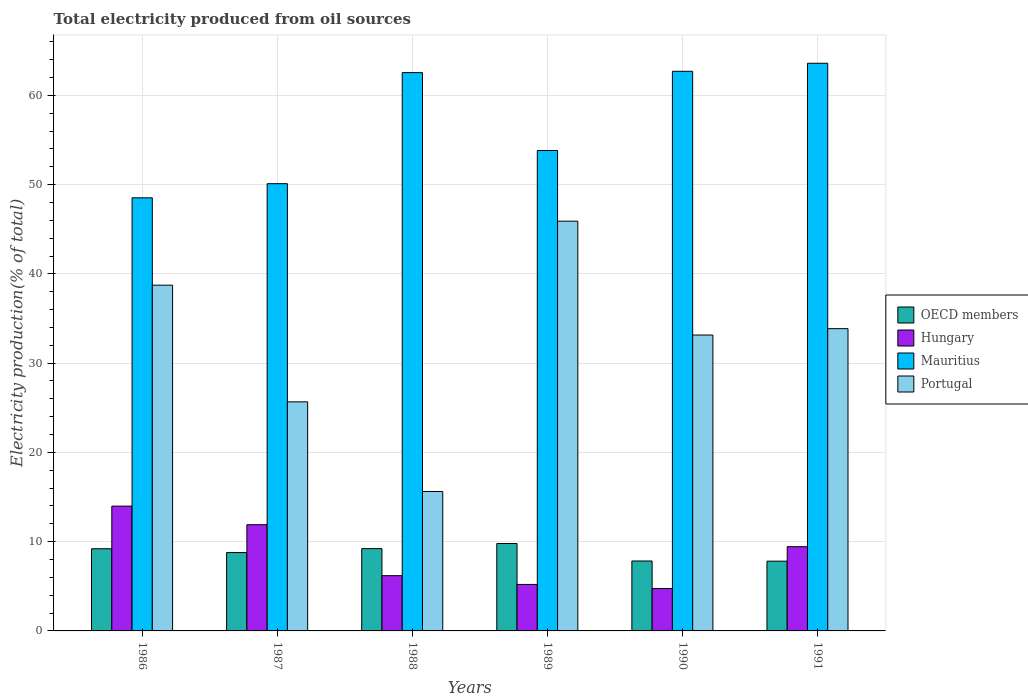How many different coloured bars are there?
Your answer should be very brief. 4. How many bars are there on the 1st tick from the left?
Your response must be concise. 4. What is the total electricity produced in Hungary in 1991?
Give a very brief answer. 9.43. Across all years, what is the maximum total electricity produced in Hungary?
Your answer should be very brief. 13.98. Across all years, what is the minimum total electricity produced in Hungary?
Provide a succinct answer. 4.75. In which year was the total electricity produced in Hungary maximum?
Offer a terse response. 1986. In which year was the total electricity produced in OECD members minimum?
Provide a succinct answer. 1991. What is the total total electricity produced in OECD members in the graph?
Keep it short and to the point. 52.65. What is the difference between the total electricity produced in Hungary in 1987 and that in 1988?
Your answer should be very brief. 5.71. What is the difference between the total electricity produced in OECD members in 1989 and the total electricity produced in Hungary in 1990?
Offer a very short reply. 5.04. What is the average total electricity produced in Portugal per year?
Your response must be concise. 32.15. In the year 1987, what is the difference between the total electricity produced in Portugal and total electricity produced in Hungary?
Ensure brevity in your answer.  13.76. What is the ratio of the total electricity produced in Mauritius in 1986 to that in 1988?
Provide a short and direct response. 0.78. Is the total electricity produced in Portugal in 1987 less than that in 1989?
Your answer should be compact. Yes. What is the difference between the highest and the second highest total electricity produced in Portugal?
Offer a very short reply. 7.17. What is the difference between the highest and the lowest total electricity produced in OECD members?
Provide a short and direct response. 1.98. In how many years, is the total electricity produced in Portugal greater than the average total electricity produced in Portugal taken over all years?
Keep it short and to the point. 4. What does the 1st bar from the left in 1991 represents?
Make the answer very short. OECD members. What does the 4th bar from the right in 1991 represents?
Your response must be concise. OECD members. Is it the case that in every year, the sum of the total electricity produced in Mauritius and total electricity produced in Portugal is greater than the total electricity produced in Hungary?
Ensure brevity in your answer.  Yes. Are the values on the major ticks of Y-axis written in scientific E-notation?
Give a very brief answer. No. Does the graph contain grids?
Your answer should be very brief. Yes. Where does the legend appear in the graph?
Make the answer very short. Center right. How are the legend labels stacked?
Give a very brief answer. Vertical. What is the title of the graph?
Provide a succinct answer. Total electricity produced from oil sources. What is the label or title of the Y-axis?
Offer a very short reply. Electricity production(% of total). What is the Electricity production(% of total) in OECD members in 1986?
Your answer should be compact. 9.21. What is the Electricity production(% of total) of Hungary in 1986?
Your answer should be very brief. 13.98. What is the Electricity production(% of total) in Mauritius in 1986?
Provide a short and direct response. 48.52. What is the Electricity production(% of total) of Portugal in 1986?
Keep it short and to the point. 38.73. What is the Electricity production(% of total) in OECD members in 1987?
Provide a short and direct response. 8.78. What is the Electricity production(% of total) in Hungary in 1987?
Your answer should be very brief. 11.9. What is the Electricity production(% of total) of Mauritius in 1987?
Offer a very short reply. 50.1. What is the Electricity production(% of total) in Portugal in 1987?
Give a very brief answer. 25.66. What is the Electricity production(% of total) of OECD members in 1988?
Your response must be concise. 9.22. What is the Electricity production(% of total) of Hungary in 1988?
Give a very brief answer. 6.19. What is the Electricity production(% of total) in Mauritius in 1988?
Keep it short and to the point. 62.55. What is the Electricity production(% of total) in Portugal in 1988?
Provide a succinct answer. 15.62. What is the Electricity production(% of total) of OECD members in 1989?
Your answer should be very brief. 9.79. What is the Electricity production(% of total) in Hungary in 1989?
Offer a very short reply. 5.21. What is the Electricity production(% of total) of Mauritius in 1989?
Your answer should be compact. 53.82. What is the Electricity production(% of total) in Portugal in 1989?
Keep it short and to the point. 45.9. What is the Electricity production(% of total) in OECD members in 1990?
Ensure brevity in your answer.  7.83. What is the Electricity production(% of total) of Hungary in 1990?
Your answer should be very brief. 4.75. What is the Electricity production(% of total) in Mauritius in 1990?
Your response must be concise. 62.69. What is the Electricity production(% of total) in Portugal in 1990?
Ensure brevity in your answer.  33.15. What is the Electricity production(% of total) in OECD members in 1991?
Provide a succinct answer. 7.82. What is the Electricity production(% of total) in Hungary in 1991?
Provide a succinct answer. 9.43. What is the Electricity production(% of total) in Mauritius in 1991?
Offer a very short reply. 63.59. What is the Electricity production(% of total) in Portugal in 1991?
Your response must be concise. 33.86. Across all years, what is the maximum Electricity production(% of total) in OECD members?
Give a very brief answer. 9.79. Across all years, what is the maximum Electricity production(% of total) in Hungary?
Your answer should be compact. 13.98. Across all years, what is the maximum Electricity production(% of total) in Mauritius?
Give a very brief answer. 63.59. Across all years, what is the maximum Electricity production(% of total) in Portugal?
Ensure brevity in your answer.  45.9. Across all years, what is the minimum Electricity production(% of total) of OECD members?
Keep it short and to the point. 7.82. Across all years, what is the minimum Electricity production(% of total) in Hungary?
Ensure brevity in your answer.  4.75. Across all years, what is the minimum Electricity production(% of total) of Mauritius?
Your answer should be very brief. 48.52. Across all years, what is the minimum Electricity production(% of total) in Portugal?
Offer a very short reply. 15.62. What is the total Electricity production(% of total) in OECD members in the graph?
Offer a very short reply. 52.65. What is the total Electricity production(% of total) in Hungary in the graph?
Your response must be concise. 51.46. What is the total Electricity production(% of total) in Mauritius in the graph?
Give a very brief answer. 341.27. What is the total Electricity production(% of total) of Portugal in the graph?
Offer a very short reply. 192.93. What is the difference between the Electricity production(% of total) of OECD members in 1986 and that in 1987?
Keep it short and to the point. 0.43. What is the difference between the Electricity production(% of total) of Hungary in 1986 and that in 1987?
Make the answer very short. 2.08. What is the difference between the Electricity production(% of total) of Mauritius in 1986 and that in 1987?
Offer a very short reply. -1.58. What is the difference between the Electricity production(% of total) of Portugal in 1986 and that in 1987?
Offer a terse response. 13.07. What is the difference between the Electricity production(% of total) in OECD members in 1986 and that in 1988?
Your answer should be compact. -0.01. What is the difference between the Electricity production(% of total) in Hungary in 1986 and that in 1988?
Give a very brief answer. 7.79. What is the difference between the Electricity production(% of total) in Mauritius in 1986 and that in 1988?
Your response must be concise. -14.03. What is the difference between the Electricity production(% of total) of Portugal in 1986 and that in 1988?
Provide a succinct answer. 23.11. What is the difference between the Electricity production(% of total) in OECD members in 1986 and that in 1989?
Offer a terse response. -0.59. What is the difference between the Electricity production(% of total) of Hungary in 1986 and that in 1989?
Give a very brief answer. 8.78. What is the difference between the Electricity production(% of total) of Mauritius in 1986 and that in 1989?
Offer a very short reply. -5.3. What is the difference between the Electricity production(% of total) in Portugal in 1986 and that in 1989?
Keep it short and to the point. -7.17. What is the difference between the Electricity production(% of total) of OECD members in 1986 and that in 1990?
Offer a very short reply. 1.37. What is the difference between the Electricity production(% of total) in Hungary in 1986 and that in 1990?
Offer a very short reply. 9.23. What is the difference between the Electricity production(% of total) in Mauritius in 1986 and that in 1990?
Your response must be concise. -14.17. What is the difference between the Electricity production(% of total) in Portugal in 1986 and that in 1990?
Your answer should be very brief. 5.58. What is the difference between the Electricity production(% of total) in OECD members in 1986 and that in 1991?
Your answer should be compact. 1.39. What is the difference between the Electricity production(% of total) in Hungary in 1986 and that in 1991?
Keep it short and to the point. 4.55. What is the difference between the Electricity production(% of total) in Mauritius in 1986 and that in 1991?
Keep it short and to the point. -15.07. What is the difference between the Electricity production(% of total) in Portugal in 1986 and that in 1991?
Make the answer very short. 4.87. What is the difference between the Electricity production(% of total) in OECD members in 1987 and that in 1988?
Ensure brevity in your answer.  -0.44. What is the difference between the Electricity production(% of total) in Hungary in 1987 and that in 1988?
Your response must be concise. 5.71. What is the difference between the Electricity production(% of total) of Mauritius in 1987 and that in 1988?
Offer a very short reply. -12.44. What is the difference between the Electricity production(% of total) of Portugal in 1987 and that in 1988?
Ensure brevity in your answer.  10.04. What is the difference between the Electricity production(% of total) in OECD members in 1987 and that in 1989?
Provide a short and direct response. -1.01. What is the difference between the Electricity production(% of total) of Hungary in 1987 and that in 1989?
Provide a short and direct response. 6.69. What is the difference between the Electricity production(% of total) in Mauritius in 1987 and that in 1989?
Keep it short and to the point. -3.72. What is the difference between the Electricity production(% of total) in Portugal in 1987 and that in 1989?
Offer a very short reply. -20.24. What is the difference between the Electricity production(% of total) in OECD members in 1987 and that in 1990?
Provide a succinct answer. 0.95. What is the difference between the Electricity production(% of total) of Hungary in 1987 and that in 1990?
Provide a short and direct response. 7.15. What is the difference between the Electricity production(% of total) in Mauritius in 1987 and that in 1990?
Make the answer very short. -12.59. What is the difference between the Electricity production(% of total) in Portugal in 1987 and that in 1990?
Ensure brevity in your answer.  -7.48. What is the difference between the Electricity production(% of total) in OECD members in 1987 and that in 1991?
Give a very brief answer. 0.96. What is the difference between the Electricity production(% of total) of Hungary in 1987 and that in 1991?
Your answer should be compact. 2.46. What is the difference between the Electricity production(% of total) in Mauritius in 1987 and that in 1991?
Your response must be concise. -13.49. What is the difference between the Electricity production(% of total) in Portugal in 1987 and that in 1991?
Keep it short and to the point. -8.2. What is the difference between the Electricity production(% of total) in OECD members in 1988 and that in 1989?
Offer a terse response. -0.57. What is the difference between the Electricity production(% of total) of Hungary in 1988 and that in 1989?
Keep it short and to the point. 0.98. What is the difference between the Electricity production(% of total) of Mauritius in 1988 and that in 1989?
Your response must be concise. 8.73. What is the difference between the Electricity production(% of total) of Portugal in 1988 and that in 1989?
Offer a very short reply. -30.28. What is the difference between the Electricity production(% of total) in OECD members in 1988 and that in 1990?
Your response must be concise. 1.39. What is the difference between the Electricity production(% of total) in Hungary in 1988 and that in 1990?
Give a very brief answer. 1.44. What is the difference between the Electricity production(% of total) of Mauritius in 1988 and that in 1990?
Offer a terse response. -0.15. What is the difference between the Electricity production(% of total) of Portugal in 1988 and that in 1990?
Provide a short and direct response. -17.53. What is the difference between the Electricity production(% of total) in OECD members in 1988 and that in 1991?
Your response must be concise. 1.4. What is the difference between the Electricity production(% of total) in Hungary in 1988 and that in 1991?
Provide a succinct answer. -3.25. What is the difference between the Electricity production(% of total) in Mauritius in 1988 and that in 1991?
Your answer should be compact. -1.05. What is the difference between the Electricity production(% of total) of Portugal in 1988 and that in 1991?
Keep it short and to the point. -18.24. What is the difference between the Electricity production(% of total) in OECD members in 1989 and that in 1990?
Your answer should be compact. 1.96. What is the difference between the Electricity production(% of total) in Hungary in 1989 and that in 1990?
Your response must be concise. 0.46. What is the difference between the Electricity production(% of total) of Mauritius in 1989 and that in 1990?
Provide a succinct answer. -8.87. What is the difference between the Electricity production(% of total) of Portugal in 1989 and that in 1990?
Provide a short and direct response. 12.76. What is the difference between the Electricity production(% of total) of OECD members in 1989 and that in 1991?
Your response must be concise. 1.98. What is the difference between the Electricity production(% of total) of Hungary in 1989 and that in 1991?
Provide a short and direct response. -4.23. What is the difference between the Electricity production(% of total) of Mauritius in 1989 and that in 1991?
Ensure brevity in your answer.  -9.77. What is the difference between the Electricity production(% of total) in Portugal in 1989 and that in 1991?
Keep it short and to the point. 12.04. What is the difference between the Electricity production(% of total) of OECD members in 1990 and that in 1991?
Your answer should be very brief. 0.02. What is the difference between the Electricity production(% of total) in Hungary in 1990 and that in 1991?
Give a very brief answer. -4.68. What is the difference between the Electricity production(% of total) of Mauritius in 1990 and that in 1991?
Give a very brief answer. -0.9. What is the difference between the Electricity production(% of total) in Portugal in 1990 and that in 1991?
Give a very brief answer. -0.71. What is the difference between the Electricity production(% of total) in OECD members in 1986 and the Electricity production(% of total) in Hungary in 1987?
Offer a terse response. -2.69. What is the difference between the Electricity production(% of total) of OECD members in 1986 and the Electricity production(% of total) of Mauritius in 1987?
Your response must be concise. -40.9. What is the difference between the Electricity production(% of total) in OECD members in 1986 and the Electricity production(% of total) in Portugal in 1987?
Give a very brief answer. -16.46. What is the difference between the Electricity production(% of total) in Hungary in 1986 and the Electricity production(% of total) in Mauritius in 1987?
Make the answer very short. -36.12. What is the difference between the Electricity production(% of total) of Hungary in 1986 and the Electricity production(% of total) of Portugal in 1987?
Keep it short and to the point. -11.68. What is the difference between the Electricity production(% of total) in Mauritius in 1986 and the Electricity production(% of total) in Portugal in 1987?
Your answer should be compact. 22.86. What is the difference between the Electricity production(% of total) of OECD members in 1986 and the Electricity production(% of total) of Hungary in 1988?
Your answer should be very brief. 3.02. What is the difference between the Electricity production(% of total) of OECD members in 1986 and the Electricity production(% of total) of Mauritius in 1988?
Offer a terse response. -53.34. What is the difference between the Electricity production(% of total) of OECD members in 1986 and the Electricity production(% of total) of Portugal in 1988?
Provide a succinct answer. -6.41. What is the difference between the Electricity production(% of total) of Hungary in 1986 and the Electricity production(% of total) of Mauritius in 1988?
Make the answer very short. -48.56. What is the difference between the Electricity production(% of total) of Hungary in 1986 and the Electricity production(% of total) of Portugal in 1988?
Make the answer very short. -1.64. What is the difference between the Electricity production(% of total) of Mauritius in 1986 and the Electricity production(% of total) of Portugal in 1988?
Your response must be concise. 32.9. What is the difference between the Electricity production(% of total) of OECD members in 1986 and the Electricity production(% of total) of Hungary in 1989?
Your answer should be very brief. 4. What is the difference between the Electricity production(% of total) in OECD members in 1986 and the Electricity production(% of total) in Mauritius in 1989?
Keep it short and to the point. -44.61. What is the difference between the Electricity production(% of total) of OECD members in 1986 and the Electricity production(% of total) of Portugal in 1989?
Your answer should be very brief. -36.7. What is the difference between the Electricity production(% of total) in Hungary in 1986 and the Electricity production(% of total) in Mauritius in 1989?
Give a very brief answer. -39.84. What is the difference between the Electricity production(% of total) of Hungary in 1986 and the Electricity production(% of total) of Portugal in 1989?
Ensure brevity in your answer.  -31.92. What is the difference between the Electricity production(% of total) in Mauritius in 1986 and the Electricity production(% of total) in Portugal in 1989?
Provide a succinct answer. 2.62. What is the difference between the Electricity production(% of total) of OECD members in 1986 and the Electricity production(% of total) of Hungary in 1990?
Give a very brief answer. 4.46. What is the difference between the Electricity production(% of total) in OECD members in 1986 and the Electricity production(% of total) in Mauritius in 1990?
Provide a short and direct response. -53.49. What is the difference between the Electricity production(% of total) of OECD members in 1986 and the Electricity production(% of total) of Portugal in 1990?
Your response must be concise. -23.94. What is the difference between the Electricity production(% of total) in Hungary in 1986 and the Electricity production(% of total) in Mauritius in 1990?
Your response must be concise. -48.71. What is the difference between the Electricity production(% of total) of Hungary in 1986 and the Electricity production(% of total) of Portugal in 1990?
Your answer should be compact. -19.17. What is the difference between the Electricity production(% of total) in Mauritius in 1986 and the Electricity production(% of total) in Portugal in 1990?
Your answer should be compact. 15.37. What is the difference between the Electricity production(% of total) in OECD members in 1986 and the Electricity production(% of total) in Hungary in 1991?
Provide a succinct answer. -0.23. What is the difference between the Electricity production(% of total) of OECD members in 1986 and the Electricity production(% of total) of Mauritius in 1991?
Offer a terse response. -54.39. What is the difference between the Electricity production(% of total) in OECD members in 1986 and the Electricity production(% of total) in Portugal in 1991?
Ensure brevity in your answer.  -24.65. What is the difference between the Electricity production(% of total) in Hungary in 1986 and the Electricity production(% of total) in Mauritius in 1991?
Your response must be concise. -49.61. What is the difference between the Electricity production(% of total) in Hungary in 1986 and the Electricity production(% of total) in Portugal in 1991?
Provide a short and direct response. -19.88. What is the difference between the Electricity production(% of total) in Mauritius in 1986 and the Electricity production(% of total) in Portugal in 1991?
Offer a very short reply. 14.66. What is the difference between the Electricity production(% of total) in OECD members in 1987 and the Electricity production(% of total) in Hungary in 1988?
Make the answer very short. 2.59. What is the difference between the Electricity production(% of total) of OECD members in 1987 and the Electricity production(% of total) of Mauritius in 1988?
Your answer should be compact. -53.77. What is the difference between the Electricity production(% of total) in OECD members in 1987 and the Electricity production(% of total) in Portugal in 1988?
Your answer should be very brief. -6.84. What is the difference between the Electricity production(% of total) in Hungary in 1987 and the Electricity production(% of total) in Mauritius in 1988?
Your answer should be compact. -50.65. What is the difference between the Electricity production(% of total) in Hungary in 1987 and the Electricity production(% of total) in Portugal in 1988?
Offer a terse response. -3.72. What is the difference between the Electricity production(% of total) in Mauritius in 1987 and the Electricity production(% of total) in Portugal in 1988?
Keep it short and to the point. 34.48. What is the difference between the Electricity production(% of total) in OECD members in 1987 and the Electricity production(% of total) in Hungary in 1989?
Your answer should be compact. 3.57. What is the difference between the Electricity production(% of total) of OECD members in 1987 and the Electricity production(% of total) of Mauritius in 1989?
Provide a short and direct response. -45.04. What is the difference between the Electricity production(% of total) of OECD members in 1987 and the Electricity production(% of total) of Portugal in 1989?
Keep it short and to the point. -37.13. What is the difference between the Electricity production(% of total) of Hungary in 1987 and the Electricity production(% of total) of Mauritius in 1989?
Make the answer very short. -41.92. What is the difference between the Electricity production(% of total) in Hungary in 1987 and the Electricity production(% of total) in Portugal in 1989?
Keep it short and to the point. -34. What is the difference between the Electricity production(% of total) of Mauritius in 1987 and the Electricity production(% of total) of Portugal in 1989?
Offer a very short reply. 4.2. What is the difference between the Electricity production(% of total) of OECD members in 1987 and the Electricity production(% of total) of Hungary in 1990?
Keep it short and to the point. 4.03. What is the difference between the Electricity production(% of total) of OECD members in 1987 and the Electricity production(% of total) of Mauritius in 1990?
Make the answer very short. -53.91. What is the difference between the Electricity production(% of total) in OECD members in 1987 and the Electricity production(% of total) in Portugal in 1990?
Give a very brief answer. -24.37. What is the difference between the Electricity production(% of total) in Hungary in 1987 and the Electricity production(% of total) in Mauritius in 1990?
Offer a terse response. -50.79. What is the difference between the Electricity production(% of total) of Hungary in 1987 and the Electricity production(% of total) of Portugal in 1990?
Offer a terse response. -21.25. What is the difference between the Electricity production(% of total) in Mauritius in 1987 and the Electricity production(% of total) in Portugal in 1990?
Offer a very short reply. 16.96. What is the difference between the Electricity production(% of total) in OECD members in 1987 and the Electricity production(% of total) in Hungary in 1991?
Give a very brief answer. -0.66. What is the difference between the Electricity production(% of total) of OECD members in 1987 and the Electricity production(% of total) of Mauritius in 1991?
Offer a very short reply. -54.82. What is the difference between the Electricity production(% of total) of OECD members in 1987 and the Electricity production(% of total) of Portugal in 1991?
Your answer should be very brief. -25.08. What is the difference between the Electricity production(% of total) in Hungary in 1987 and the Electricity production(% of total) in Mauritius in 1991?
Give a very brief answer. -51.69. What is the difference between the Electricity production(% of total) of Hungary in 1987 and the Electricity production(% of total) of Portugal in 1991?
Offer a terse response. -21.96. What is the difference between the Electricity production(% of total) of Mauritius in 1987 and the Electricity production(% of total) of Portugal in 1991?
Your answer should be very brief. 16.24. What is the difference between the Electricity production(% of total) of OECD members in 1988 and the Electricity production(% of total) of Hungary in 1989?
Provide a short and direct response. 4.01. What is the difference between the Electricity production(% of total) of OECD members in 1988 and the Electricity production(% of total) of Mauritius in 1989?
Offer a very short reply. -44.6. What is the difference between the Electricity production(% of total) in OECD members in 1988 and the Electricity production(% of total) in Portugal in 1989?
Your answer should be compact. -36.68. What is the difference between the Electricity production(% of total) of Hungary in 1988 and the Electricity production(% of total) of Mauritius in 1989?
Offer a terse response. -47.63. What is the difference between the Electricity production(% of total) of Hungary in 1988 and the Electricity production(% of total) of Portugal in 1989?
Your answer should be very brief. -39.72. What is the difference between the Electricity production(% of total) of Mauritius in 1988 and the Electricity production(% of total) of Portugal in 1989?
Offer a very short reply. 16.64. What is the difference between the Electricity production(% of total) of OECD members in 1988 and the Electricity production(% of total) of Hungary in 1990?
Provide a succinct answer. 4.47. What is the difference between the Electricity production(% of total) in OECD members in 1988 and the Electricity production(% of total) in Mauritius in 1990?
Keep it short and to the point. -53.47. What is the difference between the Electricity production(% of total) of OECD members in 1988 and the Electricity production(% of total) of Portugal in 1990?
Keep it short and to the point. -23.93. What is the difference between the Electricity production(% of total) of Hungary in 1988 and the Electricity production(% of total) of Mauritius in 1990?
Your response must be concise. -56.5. What is the difference between the Electricity production(% of total) in Hungary in 1988 and the Electricity production(% of total) in Portugal in 1990?
Keep it short and to the point. -26.96. What is the difference between the Electricity production(% of total) in Mauritius in 1988 and the Electricity production(% of total) in Portugal in 1990?
Offer a very short reply. 29.4. What is the difference between the Electricity production(% of total) of OECD members in 1988 and the Electricity production(% of total) of Hungary in 1991?
Your answer should be compact. -0.22. What is the difference between the Electricity production(% of total) of OECD members in 1988 and the Electricity production(% of total) of Mauritius in 1991?
Your answer should be very brief. -54.37. What is the difference between the Electricity production(% of total) in OECD members in 1988 and the Electricity production(% of total) in Portugal in 1991?
Give a very brief answer. -24.64. What is the difference between the Electricity production(% of total) in Hungary in 1988 and the Electricity production(% of total) in Mauritius in 1991?
Give a very brief answer. -57.41. What is the difference between the Electricity production(% of total) of Hungary in 1988 and the Electricity production(% of total) of Portugal in 1991?
Offer a terse response. -27.67. What is the difference between the Electricity production(% of total) in Mauritius in 1988 and the Electricity production(% of total) in Portugal in 1991?
Your answer should be very brief. 28.68. What is the difference between the Electricity production(% of total) in OECD members in 1989 and the Electricity production(% of total) in Hungary in 1990?
Offer a very short reply. 5.04. What is the difference between the Electricity production(% of total) of OECD members in 1989 and the Electricity production(% of total) of Mauritius in 1990?
Offer a very short reply. -52.9. What is the difference between the Electricity production(% of total) in OECD members in 1989 and the Electricity production(% of total) in Portugal in 1990?
Your answer should be compact. -23.36. What is the difference between the Electricity production(% of total) of Hungary in 1989 and the Electricity production(% of total) of Mauritius in 1990?
Offer a very short reply. -57.49. What is the difference between the Electricity production(% of total) in Hungary in 1989 and the Electricity production(% of total) in Portugal in 1990?
Your response must be concise. -27.94. What is the difference between the Electricity production(% of total) of Mauritius in 1989 and the Electricity production(% of total) of Portugal in 1990?
Give a very brief answer. 20.67. What is the difference between the Electricity production(% of total) of OECD members in 1989 and the Electricity production(% of total) of Hungary in 1991?
Your answer should be compact. 0.36. What is the difference between the Electricity production(% of total) in OECD members in 1989 and the Electricity production(% of total) in Mauritius in 1991?
Provide a short and direct response. -53.8. What is the difference between the Electricity production(% of total) of OECD members in 1989 and the Electricity production(% of total) of Portugal in 1991?
Your answer should be very brief. -24.07. What is the difference between the Electricity production(% of total) in Hungary in 1989 and the Electricity production(% of total) in Mauritius in 1991?
Your response must be concise. -58.39. What is the difference between the Electricity production(% of total) in Hungary in 1989 and the Electricity production(% of total) in Portugal in 1991?
Ensure brevity in your answer.  -28.66. What is the difference between the Electricity production(% of total) in Mauritius in 1989 and the Electricity production(% of total) in Portugal in 1991?
Offer a terse response. 19.96. What is the difference between the Electricity production(% of total) of OECD members in 1990 and the Electricity production(% of total) of Hungary in 1991?
Ensure brevity in your answer.  -1.6. What is the difference between the Electricity production(% of total) of OECD members in 1990 and the Electricity production(% of total) of Mauritius in 1991?
Give a very brief answer. -55.76. What is the difference between the Electricity production(% of total) of OECD members in 1990 and the Electricity production(% of total) of Portugal in 1991?
Make the answer very short. -26.03. What is the difference between the Electricity production(% of total) in Hungary in 1990 and the Electricity production(% of total) in Mauritius in 1991?
Give a very brief answer. -58.84. What is the difference between the Electricity production(% of total) in Hungary in 1990 and the Electricity production(% of total) in Portugal in 1991?
Offer a terse response. -29.11. What is the difference between the Electricity production(% of total) of Mauritius in 1990 and the Electricity production(% of total) of Portugal in 1991?
Keep it short and to the point. 28.83. What is the average Electricity production(% of total) of OECD members per year?
Your response must be concise. 8.77. What is the average Electricity production(% of total) in Hungary per year?
Your response must be concise. 8.58. What is the average Electricity production(% of total) of Mauritius per year?
Offer a terse response. 56.88. What is the average Electricity production(% of total) in Portugal per year?
Offer a terse response. 32.15. In the year 1986, what is the difference between the Electricity production(% of total) in OECD members and Electricity production(% of total) in Hungary?
Give a very brief answer. -4.78. In the year 1986, what is the difference between the Electricity production(% of total) in OECD members and Electricity production(% of total) in Mauritius?
Your response must be concise. -39.31. In the year 1986, what is the difference between the Electricity production(% of total) in OECD members and Electricity production(% of total) in Portugal?
Keep it short and to the point. -29.52. In the year 1986, what is the difference between the Electricity production(% of total) of Hungary and Electricity production(% of total) of Mauritius?
Keep it short and to the point. -34.54. In the year 1986, what is the difference between the Electricity production(% of total) in Hungary and Electricity production(% of total) in Portugal?
Your answer should be compact. -24.75. In the year 1986, what is the difference between the Electricity production(% of total) in Mauritius and Electricity production(% of total) in Portugal?
Provide a succinct answer. 9.79. In the year 1987, what is the difference between the Electricity production(% of total) in OECD members and Electricity production(% of total) in Hungary?
Keep it short and to the point. -3.12. In the year 1987, what is the difference between the Electricity production(% of total) of OECD members and Electricity production(% of total) of Mauritius?
Give a very brief answer. -41.32. In the year 1987, what is the difference between the Electricity production(% of total) in OECD members and Electricity production(% of total) in Portugal?
Your response must be concise. -16.88. In the year 1987, what is the difference between the Electricity production(% of total) of Hungary and Electricity production(% of total) of Mauritius?
Make the answer very short. -38.2. In the year 1987, what is the difference between the Electricity production(% of total) in Hungary and Electricity production(% of total) in Portugal?
Keep it short and to the point. -13.76. In the year 1987, what is the difference between the Electricity production(% of total) in Mauritius and Electricity production(% of total) in Portugal?
Your answer should be compact. 24.44. In the year 1988, what is the difference between the Electricity production(% of total) of OECD members and Electricity production(% of total) of Hungary?
Provide a short and direct response. 3.03. In the year 1988, what is the difference between the Electricity production(% of total) of OECD members and Electricity production(% of total) of Mauritius?
Make the answer very short. -53.33. In the year 1988, what is the difference between the Electricity production(% of total) in OECD members and Electricity production(% of total) in Portugal?
Make the answer very short. -6.4. In the year 1988, what is the difference between the Electricity production(% of total) of Hungary and Electricity production(% of total) of Mauritius?
Your answer should be very brief. -56.36. In the year 1988, what is the difference between the Electricity production(% of total) of Hungary and Electricity production(% of total) of Portugal?
Your response must be concise. -9.43. In the year 1988, what is the difference between the Electricity production(% of total) of Mauritius and Electricity production(% of total) of Portugal?
Offer a terse response. 46.93. In the year 1989, what is the difference between the Electricity production(% of total) of OECD members and Electricity production(% of total) of Hungary?
Offer a terse response. 4.59. In the year 1989, what is the difference between the Electricity production(% of total) of OECD members and Electricity production(% of total) of Mauritius?
Give a very brief answer. -44.03. In the year 1989, what is the difference between the Electricity production(% of total) in OECD members and Electricity production(% of total) in Portugal?
Your answer should be very brief. -36.11. In the year 1989, what is the difference between the Electricity production(% of total) of Hungary and Electricity production(% of total) of Mauritius?
Give a very brief answer. -48.61. In the year 1989, what is the difference between the Electricity production(% of total) of Hungary and Electricity production(% of total) of Portugal?
Ensure brevity in your answer.  -40.7. In the year 1989, what is the difference between the Electricity production(% of total) of Mauritius and Electricity production(% of total) of Portugal?
Keep it short and to the point. 7.92. In the year 1990, what is the difference between the Electricity production(% of total) of OECD members and Electricity production(% of total) of Hungary?
Offer a very short reply. 3.08. In the year 1990, what is the difference between the Electricity production(% of total) of OECD members and Electricity production(% of total) of Mauritius?
Keep it short and to the point. -54.86. In the year 1990, what is the difference between the Electricity production(% of total) in OECD members and Electricity production(% of total) in Portugal?
Provide a short and direct response. -25.31. In the year 1990, what is the difference between the Electricity production(% of total) in Hungary and Electricity production(% of total) in Mauritius?
Offer a terse response. -57.94. In the year 1990, what is the difference between the Electricity production(% of total) in Hungary and Electricity production(% of total) in Portugal?
Keep it short and to the point. -28.4. In the year 1990, what is the difference between the Electricity production(% of total) in Mauritius and Electricity production(% of total) in Portugal?
Your response must be concise. 29.54. In the year 1991, what is the difference between the Electricity production(% of total) in OECD members and Electricity production(% of total) in Hungary?
Your answer should be very brief. -1.62. In the year 1991, what is the difference between the Electricity production(% of total) of OECD members and Electricity production(% of total) of Mauritius?
Give a very brief answer. -55.78. In the year 1991, what is the difference between the Electricity production(% of total) in OECD members and Electricity production(% of total) in Portugal?
Give a very brief answer. -26.05. In the year 1991, what is the difference between the Electricity production(% of total) of Hungary and Electricity production(% of total) of Mauritius?
Ensure brevity in your answer.  -54.16. In the year 1991, what is the difference between the Electricity production(% of total) in Hungary and Electricity production(% of total) in Portugal?
Provide a short and direct response. -24.43. In the year 1991, what is the difference between the Electricity production(% of total) in Mauritius and Electricity production(% of total) in Portugal?
Provide a short and direct response. 29.73. What is the ratio of the Electricity production(% of total) of OECD members in 1986 to that in 1987?
Offer a terse response. 1.05. What is the ratio of the Electricity production(% of total) of Hungary in 1986 to that in 1987?
Ensure brevity in your answer.  1.18. What is the ratio of the Electricity production(% of total) in Mauritius in 1986 to that in 1987?
Provide a short and direct response. 0.97. What is the ratio of the Electricity production(% of total) of Portugal in 1986 to that in 1987?
Provide a succinct answer. 1.51. What is the ratio of the Electricity production(% of total) of OECD members in 1986 to that in 1988?
Your answer should be compact. 1. What is the ratio of the Electricity production(% of total) in Hungary in 1986 to that in 1988?
Ensure brevity in your answer.  2.26. What is the ratio of the Electricity production(% of total) in Mauritius in 1986 to that in 1988?
Give a very brief answer. 0.78. What is the ratio of the Electricity production(% of total) in Portugal in 1986 to that in 1988?
Offer a terse response. 2.48. What is the ratio of the Electricity production(% of total) in OECD members in 1986 to that in 1989?
Provide a short and direct response. 0.94. What is the ratio of the Electricity production(% of total) in Hungary in 1986 to that in 1989?
Offer a terse response. 2.69. What is the ratio of the Electricity production(% of total) of Mauritius in 1986 to that in 1989?
Offer a terse response. 0.9. What is the ratio of the Electricity production(% of total) in Portugal in 1986 to that in 1989?
Provide a short and direct response. 0.84. What is the ratio of the Electricity production(% of total) of OECD members in 1986 to that in 1990?
Offer a very short reply. 1.18. What is the ratio of the Electricity production(% of total) in Hungary in 1986 to that in 1990?
Ensure brevity in your answer.  2.94. What is the ratio of the Electricity production(% of total) of Mauritius in 1986 to that in 1990?
Provide a succinct answer. 0.77. What is the ratio of the Electricity production(% of total) in Portugal in 1986 to that in 1990?
Your answer should be compact. 1.17. What is the ratio of the Electricity production(% of total) of OECD members in 1986 to that in 1991?
Provide a succinct answer. 1.18. What is the ratio of the Electricity production(% of total) in Hungary in 1986 to that in 1991?
Ensure brevity in your answer.  1.48. What is the ratio of the Electricity production(% of total) of Mauritius in 1986 to that in 1991?
Ensure brevity in your answer.  0.76. What is the ratio of the Electricity production(% of total) of Portugal in 1986 to that in 1991?
Offer a terse response. 1.14. What is the ratio of the Electricity production(% of total) of OECD members in 1987 to that in 1988?
Provide a succinct answer. 0.95. What is the ratio of the Electricity production(% of total) of Hungary in 1987 to that in 1988?
Provide a short and direct response. 1.92. What is the ratio of the Electricity production(% of total) in Mauritius in 1987 to that in 1988?
Provide a short and direct response. 0.8. What is the ratio of the Electricity production(% of total) in Portugal in 1987 to that in 1988?
Your answer should be compact. 1.64. What is the ratio of the Electricity production(% of total) of OECD members in 1987 to that in 1989?
Your answer should be compact. 0.9. What is the ratio of the Electricity production(% of total) of Hungary in 1987 to that in 1989?
Ensure brevity in your answer.  2.29. What is the ratio of the Electricity production(% of total) of Mauritius in 1987 to that in 1989?
Ensure brevity in your answer.  0.93. What is the ratio of the Electricity production(% of total) in Portugal in 1987 to that in 1989?
Ensure brevity in your answer.  0.56. What is the ratio of the Electricity production(% of total) of OECD members in 1987 to that in 1990?
Ensure brevity in your answer.  1.12. What is the ratio of the Electricity production(% of total) in Hungary in 1987 to that in 1990?
Provide a short and direct response. 2.5. What is the ratio of the Electricity production(% of total) in Mauritius in 1987 to that in 1990?
Offer a very short reply. 0.8. What is the ratio of the Electricity production(% of total) in Portugal in 1987 to that in 1990?
Your response must be concise. 0.77. What is the ratio of the Electricity production(% of total) of OECD members in 1987 to that in 1991?
Provide a succinct answer. 1.12. What is the ratio of the Electricity production(% of total) in Hungary in 1987 to that in 1991?
Your answer should be compact. 1.26. What is the ratio of the Electricity production(% of total) of Mauritius in 1987 to that in 1991?
Make the answer very short. 0.79. What is the ratio of the Electricity production(% of total) of Portugal in 1987 to that in 1991?
Your answer should be very brief. 0.76. What is the ratio of the Electricity production(% of total) of OECD members in 1988 to that in 1989?
Offer a terse response. 0.94. What is the ratio of the Electricity production(% of total) of Hungary in 1988 to that in 1989?
Offer a very short reply. 1.19. What is the ratio of the Electricity production(% of total) of Mauritius in 1988 to that in 1989?
Offer a very short reply. 1.16. What is the ratio of the Electricity production(% of total) of Portugal in 1988 to that in 1989?
Offer a terse response. 0.34. What is the ratio of the Electricity production(% of total) of OECD members in 1988 to that in 1990?
Offer a terse response. 1.18. What is the ratio of the Electricity production(% of total) in Hungary in 1988 to that in 1990?
Make the answer very short. 1.3. What is the ratio of the Electricity production(% of total) of Mauritius in 1988 to that in 1990?
Offer a terse response. 1. What is the ratio of the Electricity production(% of total) in Portugal in 1988 to that in 1990?
Provide a short and direct response. 0.47. What is the ratio of the Electricity production(% of total) of OECD members in 1988 to that in 1991?
Ensure brevity in your answer.  1.18. What is the ratio of the Electricity production(% of total) in Hungary in 1988 to that in 1991?
Your answer should be very brief. 0.66. What is the ratio of the Electricity production(% of total) of Mauritius in 1988 to that in 1991?
Give a very brief answer. 0.98. What is the ratio of the Electricity production(% of total) in Portugal in 1988 to that in 1991?
Your answer should be very brief. 0.46. What is the ratio of the Electricity production(% of total) of OECD members in 1989 to that in 1990?
Ensure brevity in your answer.  1.25. What is the ratio of the Electricity production(% of total) of Hungary in 1989 to that in 1990?
Provide a succinct answer. 1.1. What is the ratio of the Electricity production(% of total) in Mauritius in 1989 to that in 1990?
Make the answer very short. 0.86. What is the ratio of the Electricity production(% of total) in Portugal in 1989 to that in 1990?
Provide a short and direct response. 1.38. What is the ratio of the Electricity production(% of total) of OECD members in 1989 to that in 1991?
Give a very brief answer. 1.25. What is the ratio of the Electricity production(% of total) in Hungary in 1989 to that in 1991?
Ensure brevity in your answer.  0.55. What is the ratio of the Electricity production(% of total) in Mauritius in 1989 to that in 1991?
Give a very brief answer. 0.85. What is the ratio of the Electricity production(% of total) in Portugal in 1989 to that in 1991?
Give a very brief answer. 1.36. What is the ratio of the Electricity production(% of total) of Hungary in 1990 to that in 1991?
Offer a terse response. 0.5. What is the ratio of the Electricity production(% of total) in Mauritius in 1990 to that in 1991?
Ensure brevity in your answer.  0.99. What is the ratio of the Electricity production(% of total) in Portugal in 1990 to that in 1991?
Provide a succinct answer. 0.98. What is the difference between the highest and the second highest Electricity production(% of total) in OECD members?
Ensure brevity in your answer.  0.57. What is the difference between the highest and the second highest Electricity production(% of total) in Hungary?
Ensure brevity in your answer.  2.08. What is the difference between the highest and the second highest Electricity production(% of total) of Mauritius?
Provide a succinct answer. 0.9. What is the difference between the highest and the second highest Electricity production(% of total) in Portugal?
Your response must be concise. 7.17. What is the difference between the highest and the lowest Electricity production(% of total) of OECD members?
Your response must be concise. 1.98. What is the difference between the highest and the lowest Electricity production(% of total) in Hungary?
Your answer should be very brief. 9.23. What is the difference between the highest and the lowest Electricity production(% of total) of Mauritius?
Your answer should be compact. 15.07. What is the difference between the highest and the lowest Electricity production(% of total) in Portugal?
Provide a short and direct response. 30.28. 